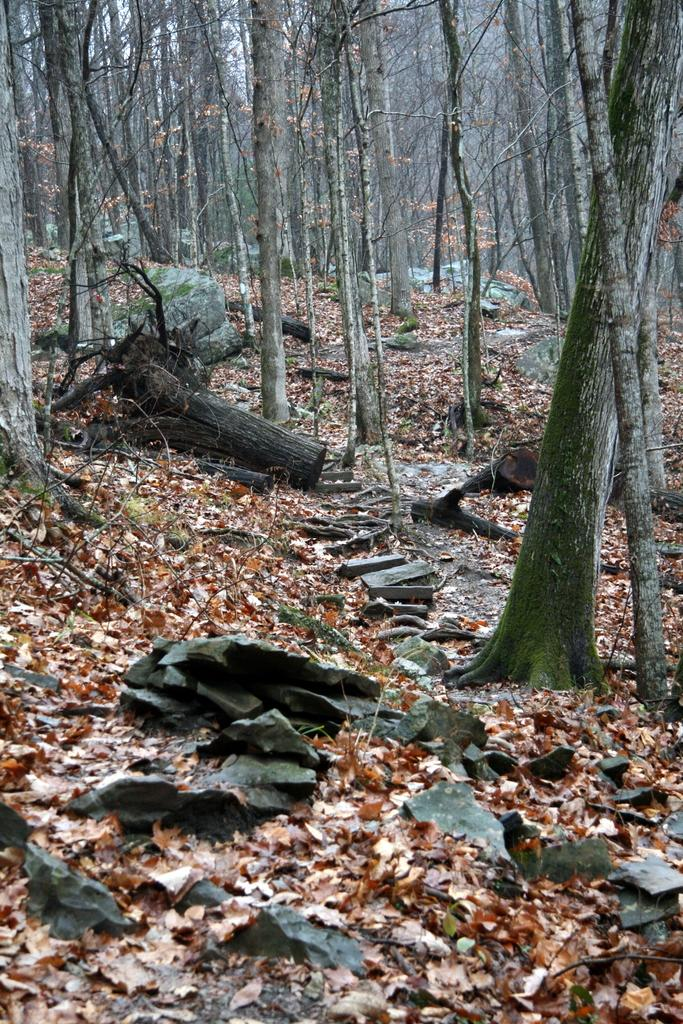What is on the ground in the image? There are leaves and a tree trunk on the ground in the image. What else can be seen in the image besides the leaves and tree trunk? There are trees visible in the image. What is the weight of the book being read by the tree in the image? There is no book or tree reading a book present in the image. How many stitches are visible on the leaves in the image? The leaves in the image do not have stitches, as they are natural plant parts. 